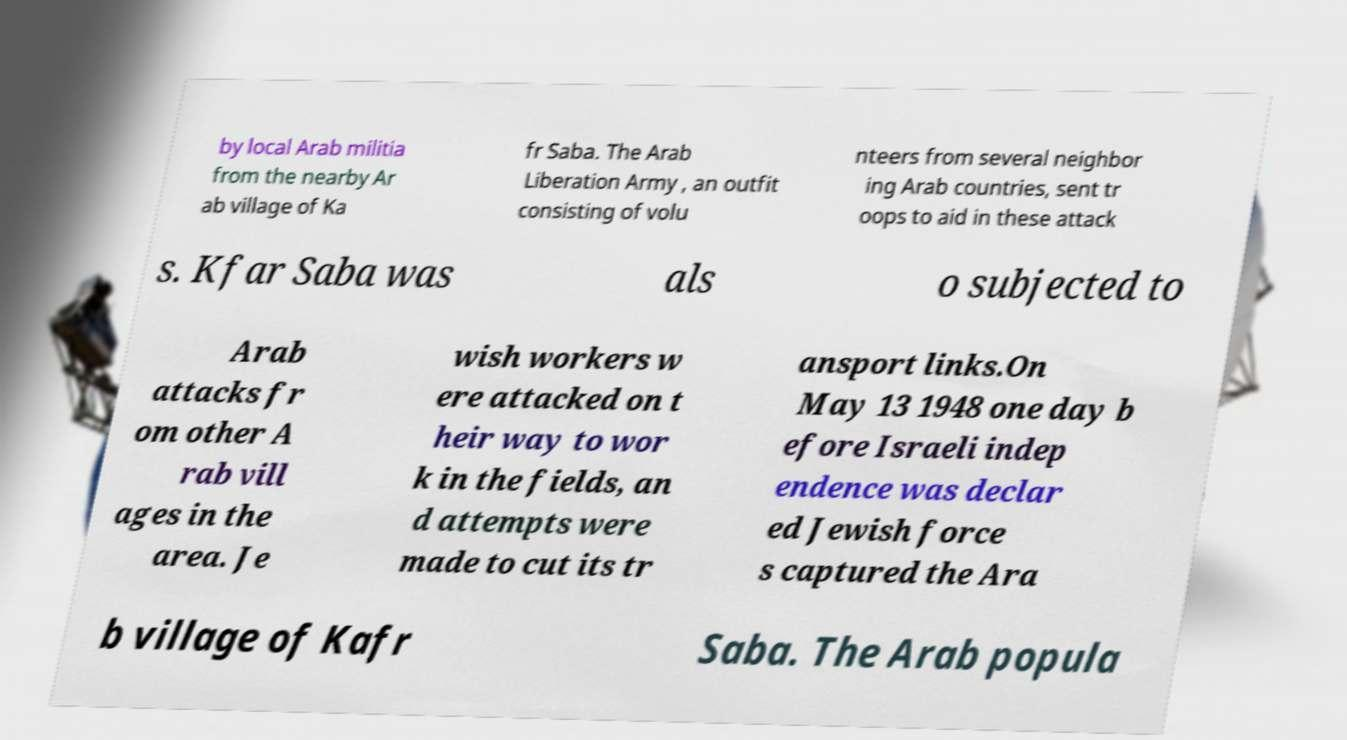Please read and relay the text visible in this image. What does it say? by local Arab militia from the nearby Ar ab village of Ka fr Saba. The Arab Liberation Army , an outfit consisting of volu nteers from several neighbor ing Arab countries, sent tr oops to aid in these attack s. Kfar Saba was als o subjected to Arab attacks fr om other A rab vill ages in the area. Je wish workers w ere attacked on t heir way to wor k in the fields, an d attempts were made to cut its tr ansport links.On May 13 1948 one day b efore Israeli indep endence was declar ed Jewish force s captured the Ara b village of Kafr Saba. The Arab popula 